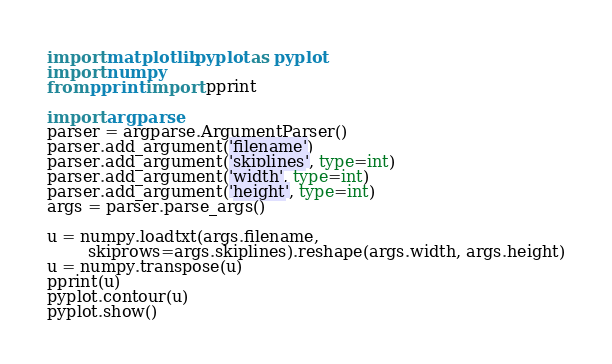<code> <loc_0><loc_0><loc_500><loc_500><_Python_>import matplotlib.pyplot as pyplot
import numpy
from pprint import pprint

import argparse
parser = argparse.ArgumentParser()
parser.add_argument('filename')
parser.add_argument('skiplines', type=int)
parser.add_argument('width', type=int)
parser.add_argument('height', type=int)
args = parser.parse_args()

u = numpy.loadtxt(args.filename,
        skiprows=args.skiplines).reshape(args.width, args.height)
u = numpy.transpose(u)
pprint(u)
pyplot.contour(u)
pyplot.show()
</code> 